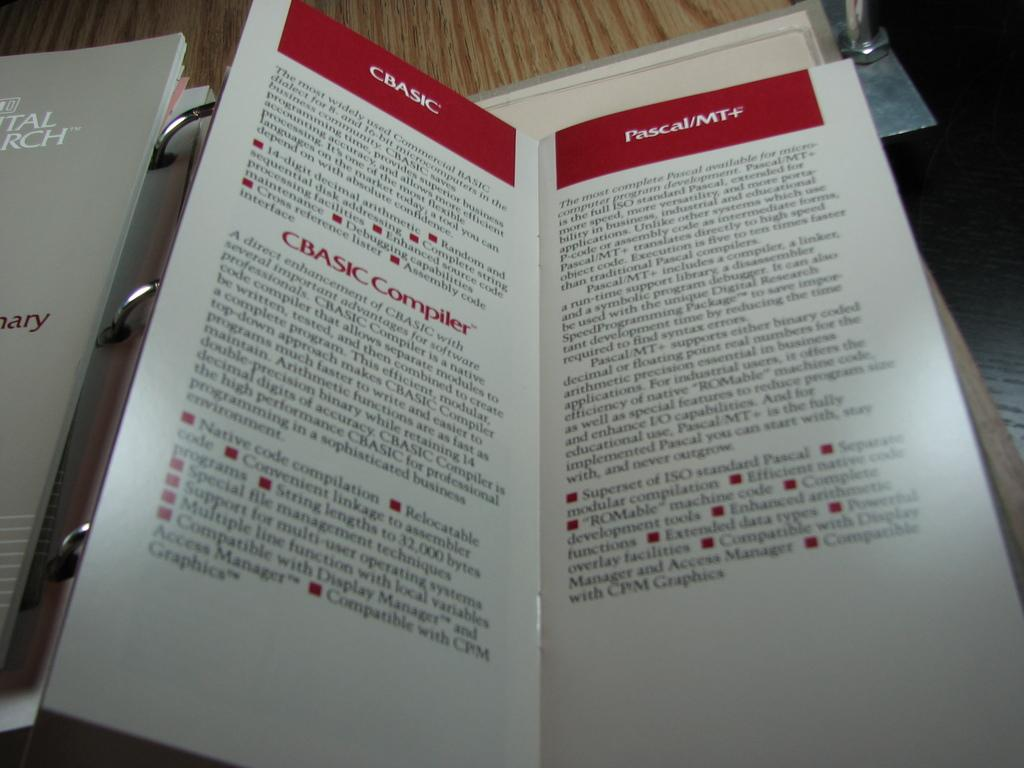Provide a one-sentence caption for the provided image. A Pumphelet of CBASIC shows some details about it. 